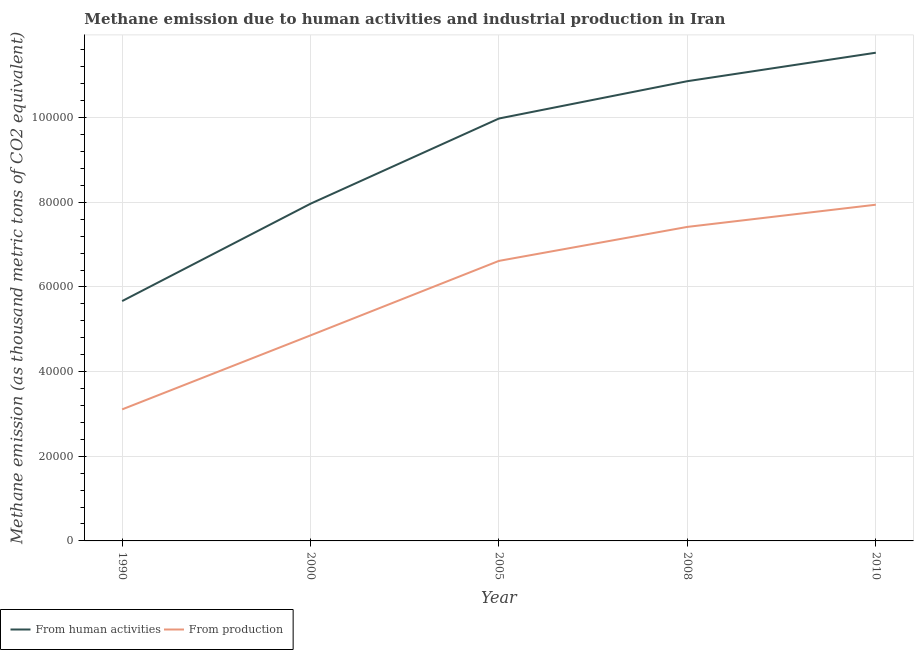How many different coloured lines are there?
Make the answer very short. 2. Does the line corresponding to amount of emissions generated from industries intersect with the line corresponding to amount of emissions from human activities?
Offer a very short reply. No. Is the number of lines equal to the number of legend labels?
Give a very brief answer. Yes. What is the amount of emissions generated from industries in 2008?
Your answer should be compact. 7.42e+04. Across all years, what is the maximum amount of emissions from human activities?
Keep it short and to the point. 1.15e+05. Across all years, what is the minimum amount of emissions generated from industries?
Give a very brief answer. 3.11e+04. In which year was the amount of emissions from human activities minimum?
Ensure brevity in your answer.  1990. What is the total amount of emissions generated from industries in the graph?
Your response must be concise. 2.99e+05. What is the difference between the amount of emissions from human activities in 1990 and that in 2010?
Offer a terse response. -5.87e+04. What is the difference between the amount of emissions from human activities in 2000 and the amount of emissions generated from industries in 2010?
Your answer should be very brief. 238.9. What is the average amount of emissions from human activities per year?
Your answer should be compact. 9.20e+04. In the year 2005, what is the difference between the amount of emissions generated from industries and amount of emissions from human activities?
Make the answer very short. -3.36e+04. What is the ratio of the amount of emissions from human activities in 1990 to that in 2010?
Give a very brief answer. 0.49. Is the amount of emissions from human activities in 1990 less than that in 2008?
Give a very brief answer. Yes. What is the difference between the highest and the second highest amount of emissions generated from industries?
Your answer should be compact. 5239.8. What is the difference between the highest and the lowest amount of emissions generated from industries?
Provide a short and direct response. 4.84e+04. In how many years, is the amount of emissions from human activities greater than the average amount of emissions from human activities taken over all years?
Your answer should be compact. 3. Is the sum of the amount of emissions generated from industries in 1990 and 2005 greater than the maximum amount of emissions from human activities across all years?
Make the answer very short. No. Is the amount of emissions from human activities strictly greater than the amount of emissions generated from industries over the years?
Your answer should be very brief. Yes. Is the amount of emissions from human activities strictly less than the amount of emissions generated from industries over the years?
Offer a very short reply. No. How many lines are there?
Give a very brief answer. 2. How many years are there in the graph?
Make the answer very short. 5. Are the values on the major ticks of Y-axis written in scientific E-notation?
Your answer should be compact. No. Does the graph contain any zero values?
Offer a very short reply. No. Where does the legend appear in the graph?
Ensure brevity in your answer.  Bottom left. How many legend labels are there?
Offer a terse response. 2. How are the legend labels stacked?
Give a very brief answer. Horizontal. What is the title of the graph?
Your response must be concise. Methane emission due to human activities and industrial production in Iran. Does "Primary education" appear as one of the legend labels in the graph?
Offer a very short reply. No. What is the label or title of the X-axis?
Offer a very short reply. Year. What is the label or title of the Y-axis?
Offer a very short reply. Methane emission (as thousand metric tons of CO2 equivalent). What is the Methane emission (as thousand metric tons of CO2 equivalent) in From human activities in 1990?
Give a very brief answer. 5.67e+04. What is the Methane emission (as thousand metric tons of CO2 equivalent) of From production in 1990?
Offer a terse response. 3.11e+04. What is the Methane emission (as thousand metric tons of CO2 equivalent) in From human activities in 2000?
Provide a short and direct response. 7.97e+04. What is the Methane emission (as thousand metric tons of CO2 equivalent) of From production in 2000?
Give a very brief answer. 4.86e+04. What is the Methane emission (as thousand metric tons of CO2 equivalent) of From human activities in 2005?
Offer a very short reply. 9.98e+04. What is the Methane emission (as thousand metric tons of CO2 equivalent) in From production in 2005?
Your answer should be compact. 6.62e+04. What is the Methane emission (as thousand metric tons of CO2 equivalent) in From human activities in 2008?
Ensure brevity in your answer.  1.09e+05. What is the Methane emission (as thousand metric tons of CO2 equivalent) in From production in 2008?
Provide a short and direct response. 7.42e+04. What is the Methane emission (as thousand metric tons of CO2 equivalent) of From human activities in 2010?
Offer a very short reply. 1.15e+05. What is the Methane emission (as thousand metric tons of CO2 equivalent) in From production in 2010?
Offer a very short reply. 7.94e+04. Across all years, what is the maximum Methane emission (as thousand metric tons of CO2 equivalent) of From human activities?
Make the answer very short. 1.15e+05. Across all years, what is the maximum Methane emission (as thousand metric tons of CO2 equivalent) of From production?
Provide a succinct answer. 7.94e+04. Across all years, what is the minimum Methane emission (as thousand metric tons of CO2 equivalent) in From human activities?
Give a very brief answer. 5.67e+04. Across all years, what is the minimum Methane emission (as thousand metric tons of CO2 equivalent) in From production?
Provide a succinct answer. 3.11e+04. What is the total Methane emission (as thousand metric tons of CO2 equivalent) in From human activities in the graph?
Make the answer very short. 4.60e+05. What is the total Methane emission (as thousand metric tons of CO2 equivalent) of From production in the graph?
Your answer should be very brief. 2.99e+05. What is the difference between the Methane emission (as thousand metric tons of CO2 equivalent) of From human activities in 1990 and that in 2000?
Your answer should be compact. -2.30e+04. What is the difference between the Methane emission (as thousand metric tons of CO2 equivalent) of From production in 1990 and that in 2000?
Make the answer very short. -1.75e+04. What is the difference between the Methane emission (as thousand metric tons of CO2 equivalent) in From human activities in 1990 and that in 2005?
Offer a very short reply. -4.31e+04. What is the difference between the Methane emission (as thousand metric tons of CO2 equivalent) of From production in 1990 and that in 2005?
Provide a short and direct response. -3.51e+04. What is the difference between the Methane emission (as thousand metric tons of CO2 equivalent) of From human activities in 1990 and that in 2008?
Provide a succinct answer. -5.19e+04. What is the difference between the Methane emission (as thousand metric tons of CO2 equivalent) of From production in 1990 and that in 2008?
Offer a very short reply. -4.31e+04. What is the difference between the Methane emission (as thousand metric tons of CO2 equivalent) of From human activities in 1990 and that in 2010?
Keep it short and to the point. -5.87e+04. What is the difference between the Methane emission (as thousand metric tons of CO2 equivalent) in From production in 1990 and that in 2010?
Offer a terse response. -4.84e+04. What is the difference between the Methane emission (as thousand metric tons of CO2 equivalent) in From human activities in 2000 and that in 2005?
Make the answer very short. -2.01e+04. What is the difference between the Methane emission (as thousand metric tons of CO2 equivalent) of From production in 2000 and that in 2005?
Give a very brief answer. -1.76e+04. What is the difference between the Methane emission (as thousand metric tons of CO2 equivalent) of From human activities in 2000 and that in 2008?
Keep it short and to the point. -2.89e+04. What is the difference between the Methane emission (as thousand metric tons of CO2 equivalent) of From production in 2000 and that in 2008?
Ensure brevity in your answer.  -2.56e+04. What is the difference between the Methane emission (as thousand metric tons of CO2 equivalent) in From human activities in 2000 and that in 2010?
Keep it short and to the point. -3.57e+04. What is the difference between the Methane emission (as thousand metric tons of CO2 equivalent) in From production in 2000 and that in 2010?
Offer a terse response. -3.09e+04. What is the difference between the Methane emission (as thousand metric tons of CO2 equivalent) of From human activities in 2005 and that in 2008?
Ensure brevity in your answer.  -8816.1. What is the difference between the Methane emission (as thousand metric tons of CO2 equivalent) of From production in 2005 and that in 2008?
Provide a short and direct response. -8028.1. What is the difference between the Methane emission (as thousand metric tons of CO2 equivalent) in From human activities in 2005 and that in 2010?
Your response must be concise. -1.55e+04. What is the difference between the Methane emission (as thousand metric tons of CO2 equivalent) of From production in 2005 and that in 2010?
Offer a very short reply. -1.33e+04. What is the difference between the Methane emission (as thousand metric tons of CO2 equivalent) in From human activities in 2008 and that in 2010?
Your answer should be very brief. -6726.3. What is the difference between the Methane emission (as thousand metric tons of CO2 equivalent) of From production in 2008 and that in 2010?
Your answer should be compact. -5239.8. What is the difference between the Methane emission (as thousand metric tons of CO2 equivalent) of From human activities in 1990 and the Methane emission (as thousand metric tons of CO2 equivalent) of From production in 2000?
Offer a very short reply. 8101.6. What is the difference between the Methane emission (as thousand metric tons of CO2 equivalent) in From human activities in 1990 and the Methane emission (as thousand metric tons of CO2 equivalent) in From production in 2005?
Provide a short and direct response. -9496.2. What is the difference between the Methane emission (as thousand metric tons of CO2 equivalent) in From human activities in 1990 and the Methane emission (as thousand metric tons of CO2 equivalent) in From production in 2008?
Provide a succinct answer. -1.75e+04. What is the difference between the Methane emission (as thousand metric tons of CO2 equivalent) of From human activities in 1990 and the Methane emission (as thousand metric tons of CO2 equivalent) of From production in 2010?
Ensure brevity in your answer.  -2.28e+04. What is the difference between the Methane emission (as thousand metric tons of CO2 equivalent) of From human activities in 2000 and the Methane emission (as thousand metric tons of CO2 equivalent) of From production in 2005?
Offer a very short reply. 1.35e+04. What is the difference between the Methane emission (as thousand metric tons of CO2 equivalent) in From human activities in 2000 and the Methane emission (as thousand metric tons of CO2 equivalent) in From production in 2008?
Your answer should be compact. 5478.7. What is the difference between the Methane emission (as thousand metric tons of CO2 equivalent) of From human activities in 2000 and the Methane emission (as thousand metric tons of CO2 equivalent) of From production in 2010?
Make the answer very short. 238.9. What is the difference between the Methane emission (as thousand metric tons of CO2 equivalent) of From human activities in 2005 and the Methane emission (as thousand metric tons of CO2 equivalent) of From production in 2008?
Provide a short and direct response. 2.56e+04. What is the difference between the Methane emission (as thousand metric tons of CO2 equivalent) in From human activities in 2005 and the Methane emission (as thousand metric tons of CO2 equivalent) in From production in 2010?
Provide a short and direct response. 2.04e+04. What is the difference between the Methane emission (as thousand metric tons of CO2 equivalent) of From human activities in 2008 and the Methane emission (as thousand metric tons of CO2 equivalent) of From production in 2010?
Keep it short and to the point. 2.92e+04. What is the average Methane emission (as thousand metric tons of CO2 equivalent) in From human activities per year?
Provide a succinct answer. 9.20e+04. What is the average Methane emission (as thousand metric tons of CO2 equivalent) of From production per year?
Provide a succinct answer. 5.99e+04. In the year 1990, what is the difference between the Methane emission (as thousand metric tons of CO2 equivalent) in From human activities and Methane emission (as thousand metric tons of CO2 equivalent) in From production?
Provide a succinct answer. 2.56e+04. In the year 2000, what is the difference between the Methane emission (as thousand metric tons of CO2 equivalent) of From human activities and Methane emission (as thousand metric tons of CO2 equivalent) of From production?
Ensure brevity in your answer.  3.11e+04. In the year 2005, what is the difference between the Methane emission (as thousand metric tons of CO2 equivalent) of From human activities and Methane emission (as thousand metric tons of CO2 equivalent) of From production?
Your answer should be compact. 3.36e+04. In the year 2008, what is the difference between the Methane emission (as thousand metric tons of CO2 equivalent) of From human activities and Methane emission (as thousand metric tons of CO2 equivalent) of From production?
Your answer should be very brief. 3.44e+04. In the year 2010, what is the difference between the Methane emission (as thousand metric tons of CO2 equivalent) in From human activities and Methane emission (as thousand metric tons of CO2 equivalent) in From production?
Your answer should be compact. 3.59e+04. What is the ratio of the Methane emission (as thousand metric tons of CO2 equivalent) of From human activities in 1990 to that in 2000?
Your answer should be compact. 0.71. What is the ratio of the Methane emission (as thousand metric tons of CO2 equivalent) in From production in 1990 to that in 2000?
Offer a terse response. 0.64. What is the ratio of the Methane emission (as thousand metric tons of CO2 equivalent) of From human activities in 1990 to that in 2005?
Make the answer very short. 0.57. What is the ratio of the Methane emission (as thousand metric tons of CO2 equivalent) of From production in 1990 to that in 2005?
Provide a short and direct response. 0.47. What is the ratio of the Methane emission (as thousand metric tons of CO2 equivalent) of From human activities in 1990 to that in 2008?
Offer a terse response. 0.52. What is the ratio of the Methane emission (as thousand metric tons of CO2 equivalent) in From production in 1990 to that in 2008?
Offer a terse response. 0.42. What is the ratio of the Methane emission (as thousand metric tons of CO2 equivalent) in From human activities in 1990 to that in 2010?
Provide a short and direct response. 0.49. What is the ratio of the Methane emission (as thousand metric tons of CO2 equivalent) of From production in 1990 to that in 2010?
Offer a very short reply. 0.39. What is the ratio of the Methane emission (as thousand metric tons of CO2 equivalent) in From human activities in 2000 to that in 2005?
Make the answer very short. 0.8. What is the ratio of the Methane emission (as thousand metric tons of CO2 equivalent) of From production in 2000 to that in 2005?
Provide a short and direct response. 0.73. What is the ratio of the Methane emission (as thousand metric tons of CO2 equivalent) of From human activities in 2000 to that in 2008?
Your answer should be very brief. 0.73. What is the ratio of the Methane emission (as thousand metric tons of CO2 equivalent) of From production in 2000 to that in 2008?
Provide a short and direct response. 0.65. What is the ratio of the Methane emission (as thousand metric tons of CO2 equivalent) of From human activities in 2000 to that in 2010?
Make the answer very short. 0.69. What is the ratio of the Methane emission (as thousand metric tons of CO2 equivalent) of From production in 2000 to that in 2010?
Give a very brief answer. 0.61. What is the ratio of the Methane emission (as thousand metric tons of CO2 equivalent) in From human activities in 2005 to that in 2008?
Offer a very short reply. 0.92. What is the ratio of the Methane emission (as thousand metric tons of CO2 equivalent) in From production in 2005 to that in 2008?
Give a very brief answer. 0.89. What is the ratio of the Methane emission (as thousand metric tons of CO2 equivalent) in From human activities in 2005 to that in 2010?
Ensure brevity in your answer.  0.87. What is the ratio of the Methane emission (as thousand metric tons of CO2 equivalent) in From production in 2005 to that in 2010?
Provide a short and direct response. 0.83. What is the ratio of the Methane emission (as thousand metric tons of CO2 equivalent) in From human activities in 2008 to that in 2010?
Your answer should be compact. 0.94. What is the ratio of the Methane emission (as thousand metric tons of CO2 equivalent) in From production in 2008 to that in 2010?
Ensure brevity in your answer.  0.93. What is the difference between the highest and the second highest Methane emission (as thousand metric tons of CO2 equivalent) of From human activities?
Offer a terse response. 6726.3. What is the difference between the highest and the second highest Methane emission (as thousand metric tons of CO2 equivalent) of From production?
Your response must be concise. 5239.8. What is the difference between the highest and the lowest Methane emission (as thousand metric tons of CO2 equivalent) in From human activities?
Provide a succinct answer. 5.87e+04. What is the difference between the highest and the lowest Methane emission (as thousand metric tons of CO2 equivalent) in From production?
Give a very brief answer. 4.84e+04. 